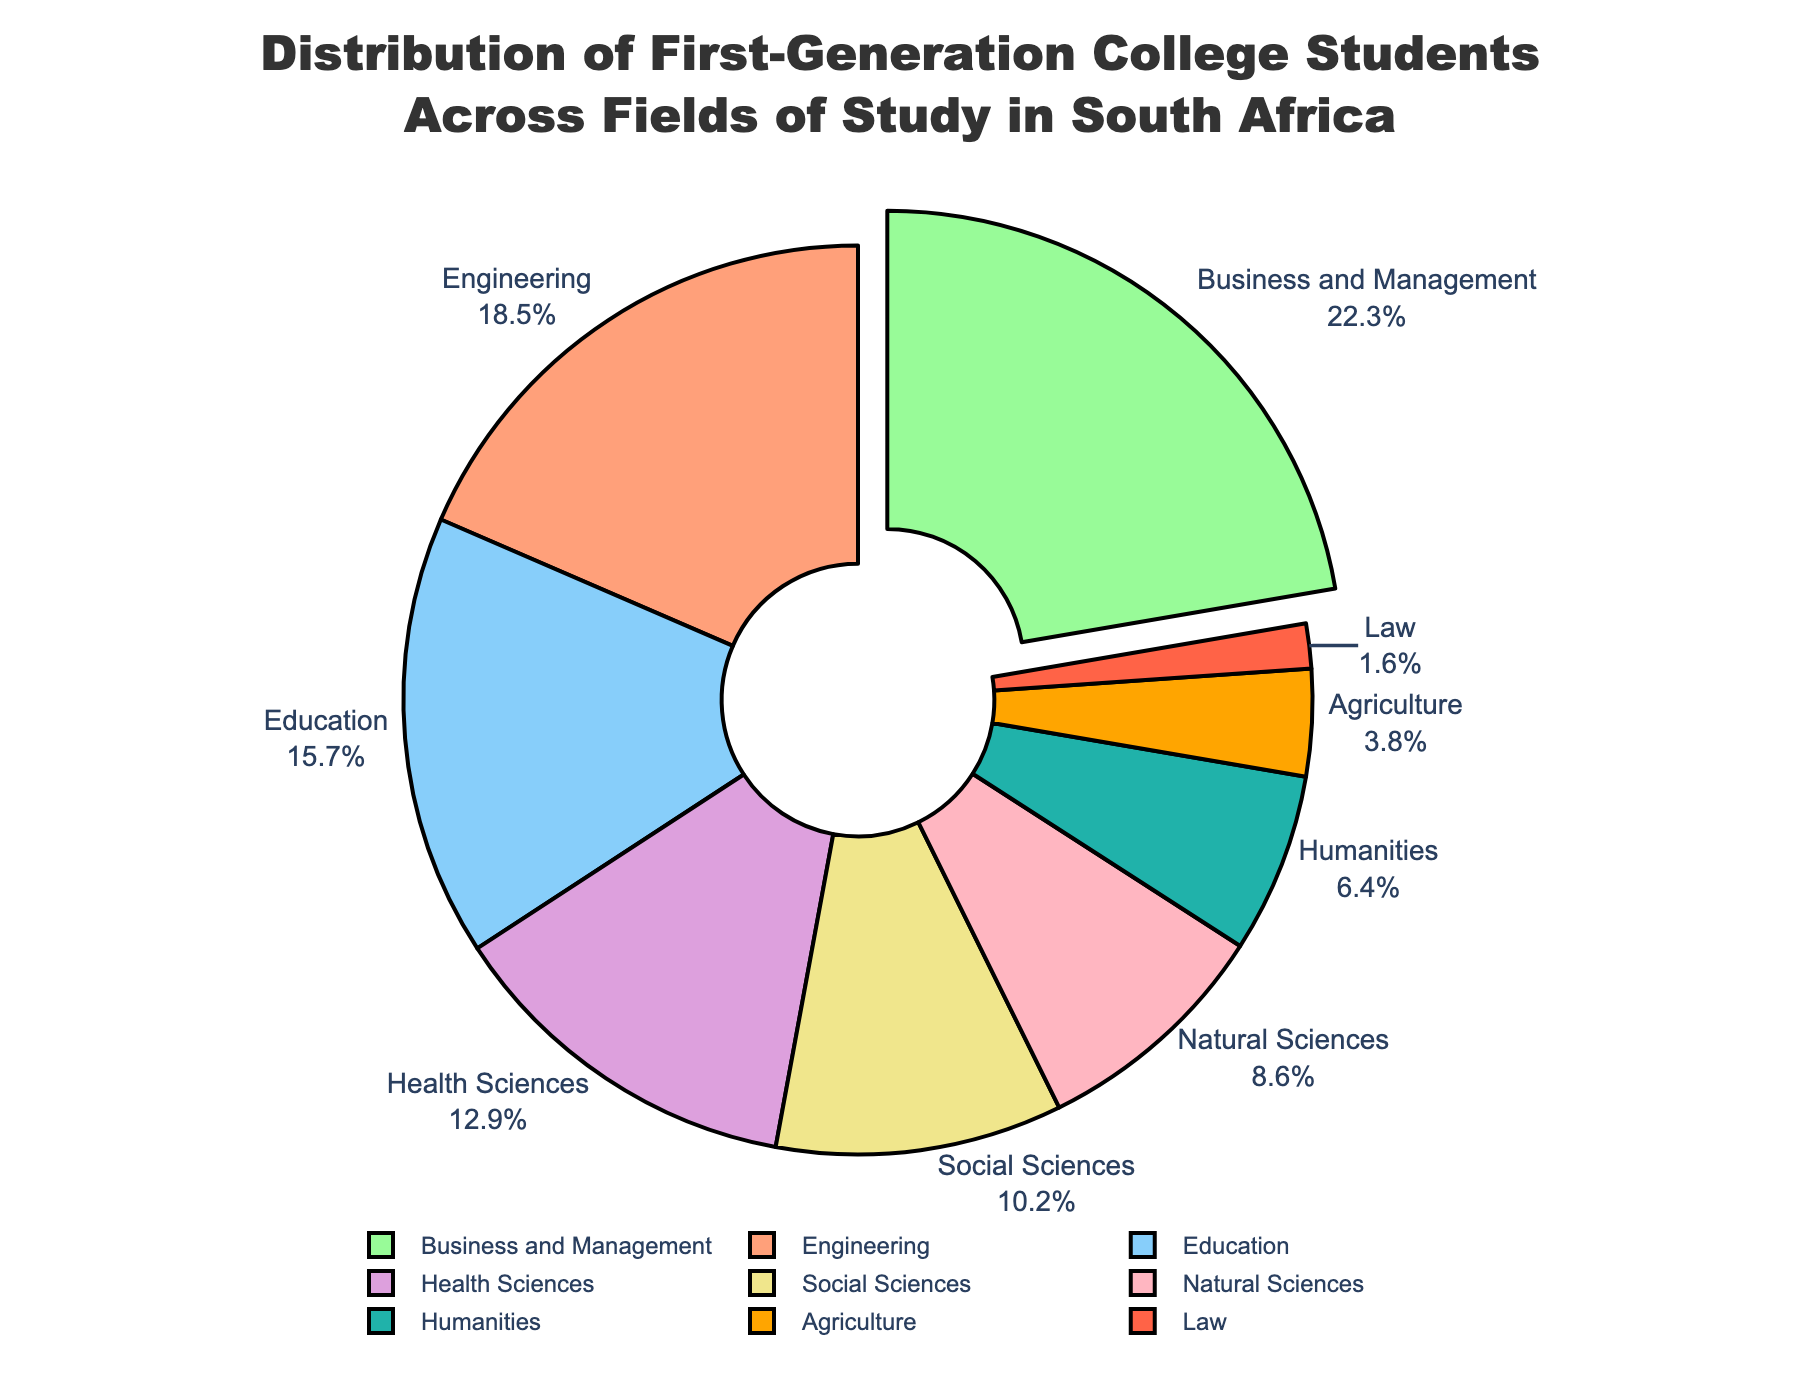What is the most popular field of study among first-generation college students in South Africa? The largest section of the pie chart, which is also pulled out slightly, represents Business and Management, indicating it is the most popular field of study.
Answer: Business and Management Which field of study has the smallest percentage of first-generation college students? The smallest section of the pie chart represents Law, indicating it has the smallest percentage of first-generation college students.
Answer: Law How does the percentage of students in Engineering compare to those in Business and Management? The pie chart shows that Engineering has 18.5% and Business and Management has 22.3%, so Business and Management has a higher percentage.
Answer: Business and Management What is the combined percentage of students in Health Sciences and Social Sciences? Health Sciences has 12.9% and Social Sciences has 10.2%. Adding these percentages gives 12.9% + 10.2% = 23.1%.
Answer: 23.1% Which fields of study have a percentage higher than 15%? By examining the pie chart, the fields with percentages higher than 15% are Business and Management (22.3%), Engineering (18.5%), and Education (15.7%).
Answer: Business and Management, Engineering, Education How does the percentage of students in Humanities compare to those in Natural Sciences? The pie chart shows Humanities at 6.4% and Natural Sciences at 8.6%, so Natural Sciences has a higher percentage than Humanities.
Answer: Natural Sciences What is the median percentage of all the fields of study? Listing the percentages in ascending order: 1.6, 3.8, 6.4, 8.6, 10.2, 12.9, 15.7, 18.5, 22.3. The middle value is the 5th (since there are 9 values) which is 10.2%.
Answer: 10.2% What is the difference between the percentage of students in Business and Management and the percentage in Agriculture? Business and Management has 22.3% and Agriculture has 3.8%. The difference is 22.3% - 3.8% = 18.5%.
Answer: 18.5% Which color represents the field of Education in the pie chart? The color representing the field of Education would need to be identified based on the chart's color legend. By matching field names to colors, Education is represented by a purple color.
Answer: Purple 